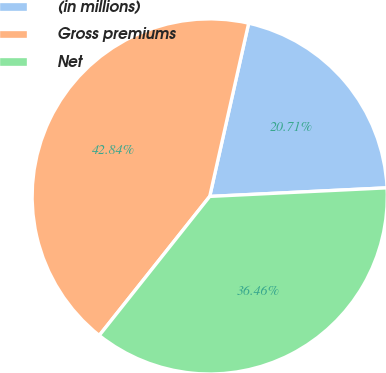<chart> <loc_0><loc_0><loc_500><loc_500><pie_chart><fcel>(in millions)<fcel>Gross premiums<fcel>Net<nl><fcel>20.71%<fcel>42.84%<fcel>36.46%<nl></chart> 